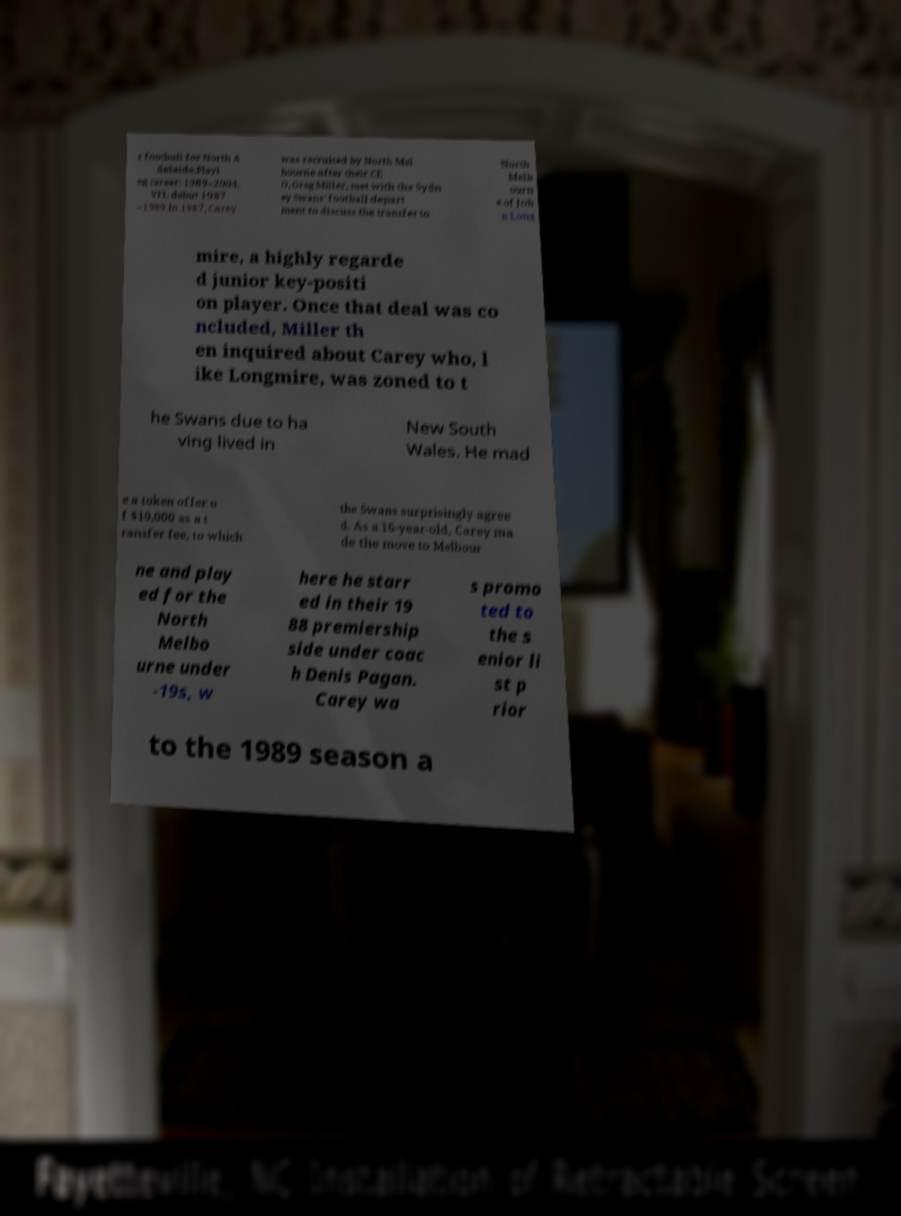Please identify and transcribe the text found in this image. r football for North A delaide.Playi ng career: 1989–2004. VFL debut 1987 –1989.In 1987, Carey was recruited by North Mel bourne after their CE O, Greg Miller, met with the Sydn ey Swans' football depart ment to discuss the transfer to North Melb ourn e of Joh n Long mire, a highly regarde d junior key-positi on player. Once that deal was co ncluded, Miller th en inquired about Carey who, l ike Longmire, was zoned to t he Swans due to ha ving lived in New South Wales. He mad e a token offer o f $10,000 as a t ransfer fee, to which the Swans surprisingly agree d. As a 16-year-old, Carey ma de the move to Melbour ne and play ed for the North Melbo urne under -19s, w here he starr ed in their 19 88 premiership side under coac h Denis Pagan. Carey wa s promo ted to the s enior li st p rior to the 1989 season a 